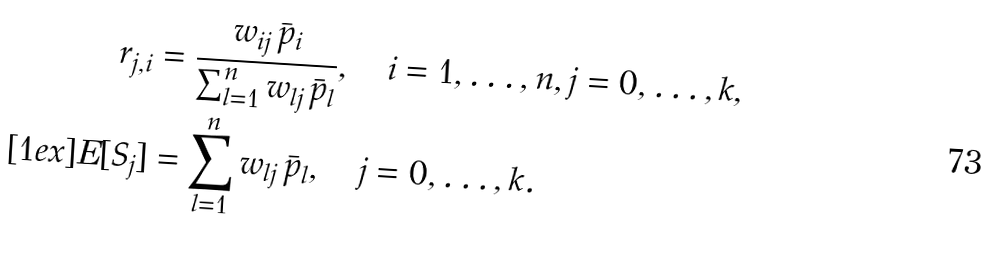Convert formula to latex. <formula><loc_0><loc_0><loc_500><loc_500>r _ { j , i } & = \frac { w _ { i j } \, \bar { p } _ { i } } { \sum _ { l = 1 } ^ { n } w _ { l j } \, \bar { p } _ { l } } , \quad i = 1 , \dots , n , j = 0 , \dots , k , \\ [ 1 e x ] E [ S _ { j } ] & = \sum _ { l = 1 } ^ { n } w _ { l j } \, \bar { p } _ { l } , \quad j = 0 , \dots , k .</formula> 